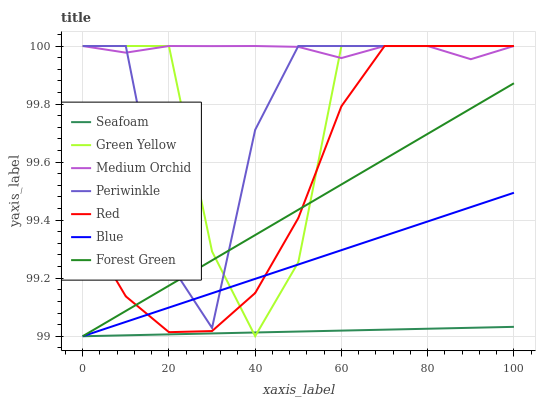Does Seafoam have the minimum area under the curve?
Answer yes or no. Yes. Does Medium Orchid have the maximum area under the curve?
Answer yes or no. Yes. Does Medium Orchid have the minimum area under the curve?
Answer yes or no. No. Does Seafoam have the maximum area under the curve?
Answer yes or no. No. Is Seafoam the smoothest?
Answer yes or no. Yes. Is Green Yellow the roughest?
Answer yes or no. Yes. Is Medium Orchid the smoothest?
Answer yes or no. No. Is Medium Orchid the roughest?
Answer yes or no. No. Does Blue have the lowest value?
Answer yes or no. Yes. Does Medium Orchid have the lowest value?
Answer yes or no. No. Does Red have the highest value?
Answer yes or no. Yes. Does Seafoam have the highest value?
Answer yes or no. No. Is Seafoam less than Periwinkle?
Answer yes or no. Yes. Is Medium Orchid greater than Seafoam?
Answer yes or no. Yes. Does Periwinkle intersect Blue?
Answer yes or no. Yes. Is Periwinkle less than Blue?
Answer yes or no. No. Is Periwinkle greater than Blue?
Answer yes or no. No. Does Seafoam intersect Periwinkle?
Answer yes or no. No. 